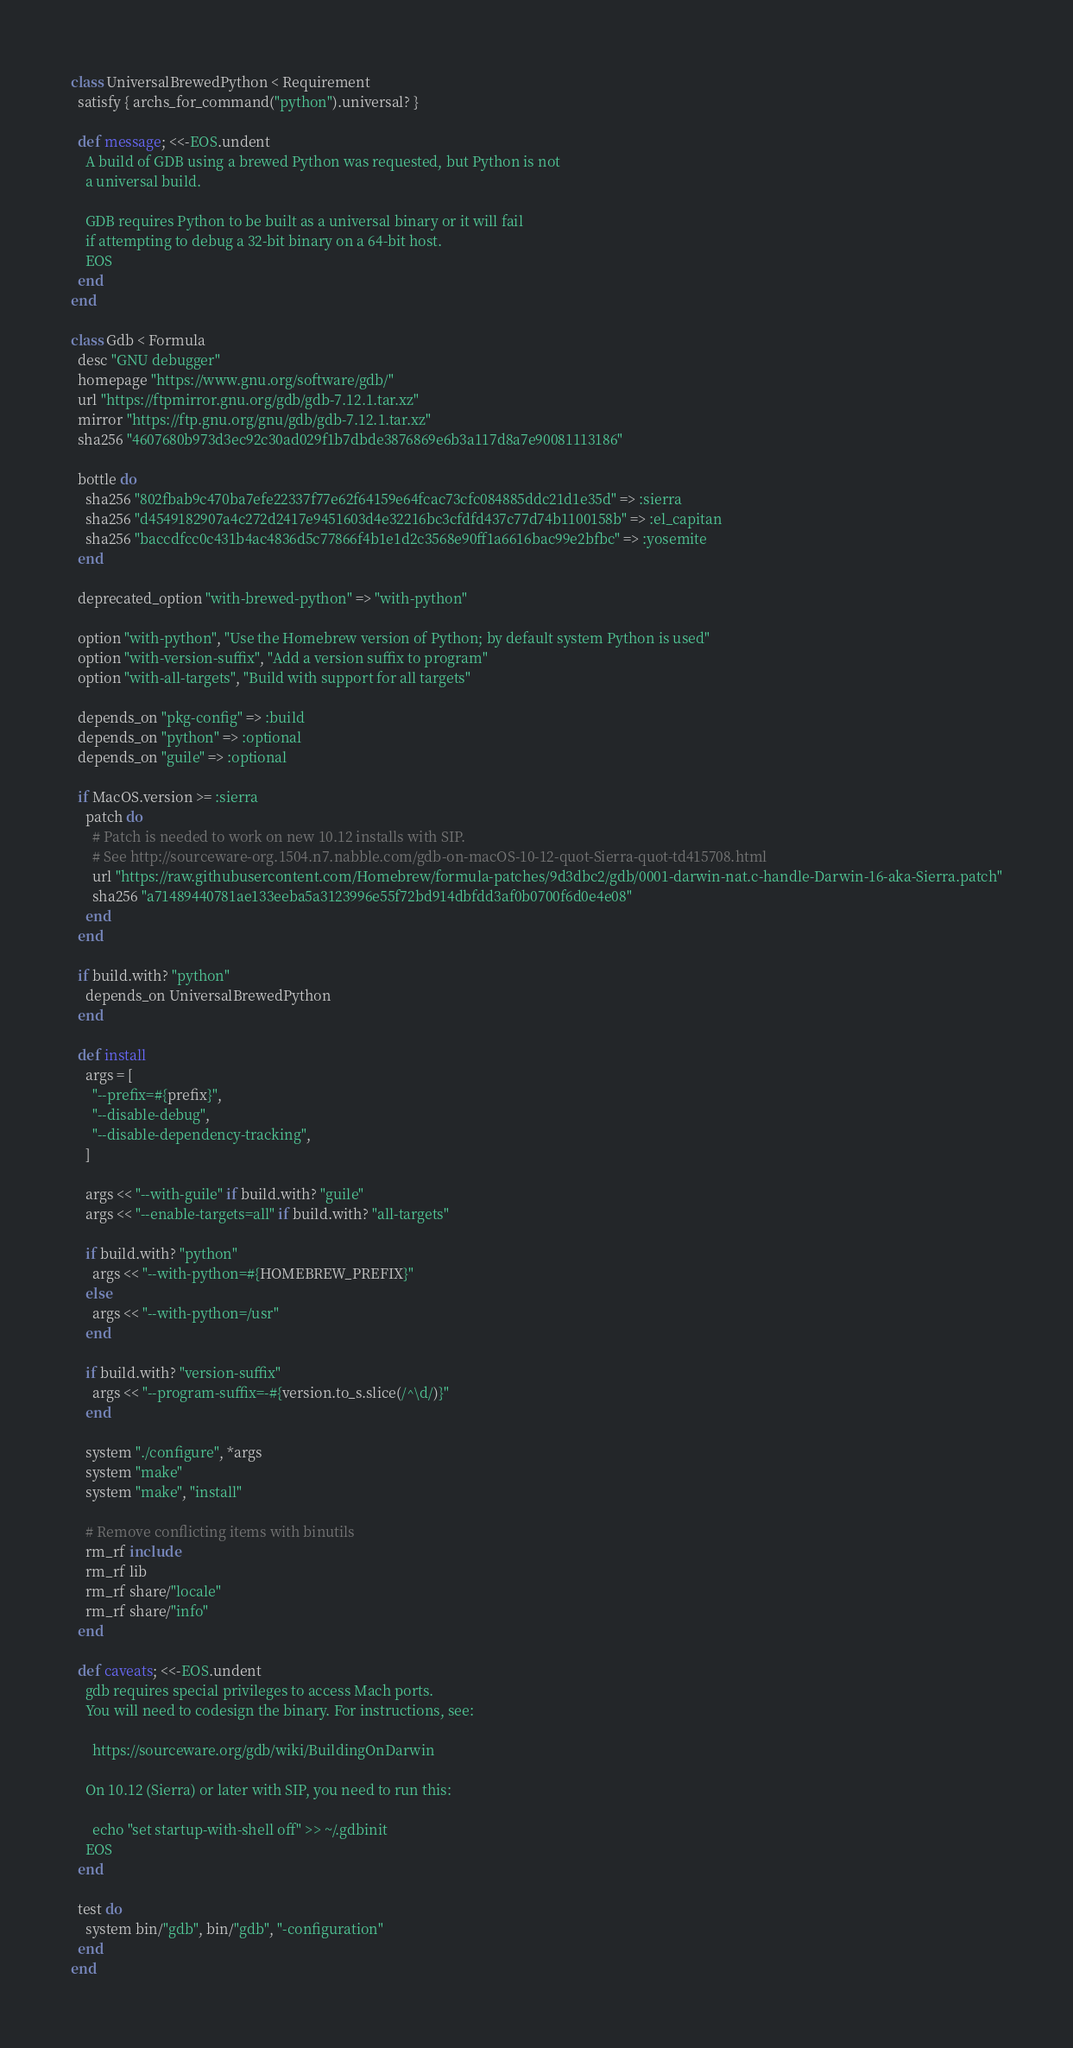<code> <loc_0><loc_0><loc_500><loc_500><_Ruby_>class UniversalBrewedPython < Requirement
  satisfy { archs_for_command("python").universal? }

  def message; <<-EOS.undent
    A build of GDB using a brewed Python was requested, but Python is not
    a universal build.

    GDB requires Python to be built as a universal binary or it will fail
    if attempting to debug a 32-bit binary on a 64-bit host.
    EOS
  end
end

class Gdb < Formula
  desc "GNU debugger"
  homepage "https://www.gnu.org/software/gdb/"
  url "https://ftpmirror.gnu.org/gdb/gdb-7.12.1.tar.xz"
  mirror "https://ftp.gnu.org/gnu/gdb/gdb-7.12.1.tar.xz"
  sha256 "4607680b973d3ec92c30ad029f1b7dbde3876869e6b3a117d8a7e90081113186"

  bottle do
    sha256 "802fbab9c470ba7efe22337f77e62f64159e64fcac73cfc084885ddc21d1e35d" => :sierra
    sha256 "d4549182907a4c272d2417e9451603d4e32216bc3cfdfd437c77d74b1100158b" => :el_capitan
    sha256 "baccdfcc0c431b4ac4836d5c77866f4b1e1d2c3568e90ff1a6616bac99e2bfbc" => :yosemite
  end

  deprecated_option "with-brewed-python" => "with-python"

  option "with-python", "Use the Homebrew version of Python; by default system Python is used"
  option "with-version-suffix", "Add a version suffix to program"
  option "with-all-targets", "Build with support for all targets"

  depends_on "pkg-config" => :build
  depends_on "python" => :optional
  depends_on "guile" => :optional

  if MacOS.version >= :sierra
    patch do
      # Patch is needed to work on new 10.12 installs with SIP.
      # See http://sourceware-org.1504.n7.nabble.com/gdb-on-macOS-10-12-quot-Sierra-quot-td415708.html
      url "https://raw.githubusercontent.com/Homebrew/formula-patches/9d3dbc2/gdb/0001-darwin-nat.c-handle-Darwin-16-aka-Sierra.patch"
      sha256 "a71489440781ae133eeba5a3123996e55f72bd914dbfdd3af0b0700f6d0e4e08"
    end
  end

  if build.with? "python"
    depends_on UniversalBrewedPython
  end

  def install
    args = [
      "--prefix=#{prefix}",
      "--disable-debug",
      "--disable-dependency-tracking",
    ]

    args << "--with-guile" if build.with? "guile"
    args << "--enable-targets=all" if build.with? "all-targets"

    if build.with? "python"
      args << "--with-python=#{HOMEBREW_PREFIX}"
    else
      args << "--with-python=/usr"
    end

    if build.with? "version-suffix"
      args << "--program-suffix=-#{version.to_s.slice(/^\d/)}"
    end

    system "./configure", *args
    system "make"
    system "make", "install"

    # Remove conflicting items with binutils
    rm_rf include
    rm_rf lib
    rm_rf share/"locale"
    rm_rf share/"info"
  end

  def caveats; <<-EOS.undent
    gdb requires special privileges to access Mach ports.
    You will need to codesign the binary. For instructions, see:

      https://sourceware.org/gdb/wiki/BuildingOnDarwin

    On 10.12 (Sierra) or later with SIP, you need to run this:

      echo "set startup-with-shell off" >> ~/.gdbinit
    EOS
  end

  test do
    system bin/"gdb", bin/"gdb", "-configuration"
  end
end
</code> 